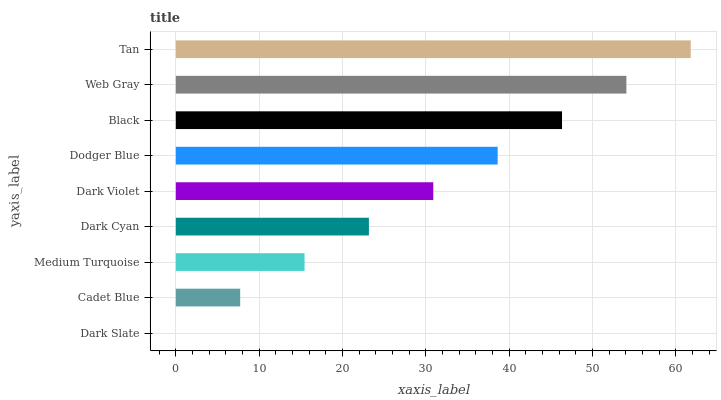Is Dark Slate the minimum?
Answer yes or no. Yes. Is Tan the maximum?
Answer yes or no. Yes. Is Cadet Blue the minimum?
Answer yes or no. No. Is Cadet Blue the maximum?
Answer yes or no. No. Is Cadet Blue greater than Dark Slate?
Answer yes or no. Yes. Is Dark Slate less than Cadet Blue?
Answer yes or no. Yes. Is Dark Slate greater than Cadet Blue?
Answer yes or no. No. Is Cadet Blue less than Dark Slate?
Answer yes or no. No. Is Dark Violet the high median?
Answer yes or no. Yes. Is Dark Violet the low median?
Answer yes or no. Yes. Is Dark Slate the high median?
Answer yes or no. No. Is Cadet Blue the low median?
Answer yes or no. No. 